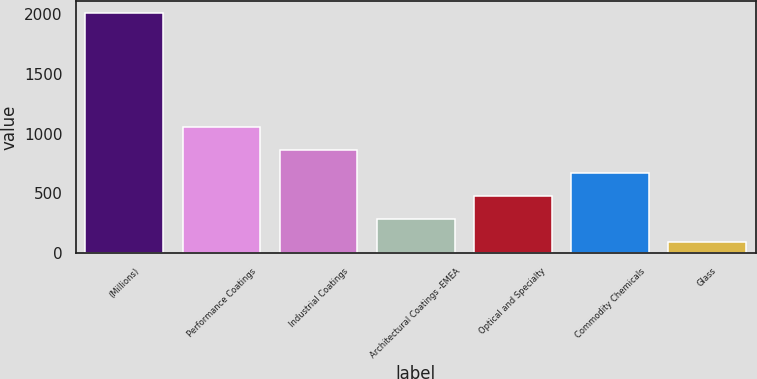Convert chart. <chart><loc_0><loc_0><loc_500><loc_500><bar_chart><fcel>(Millions)<fcel>Performance Coatings<fcel>Industrial Coatings<fcel>Architectural Coatings -EMEA<fcel>Optical and Specialty<fcel>Commodity Chemicals<fcel>Glass<nl><fcel>2011<fcel>1054<fcel>862.6<fcel>288.4<fcel>479.8<fcel>671.2<fcel>97<nl></chart> 